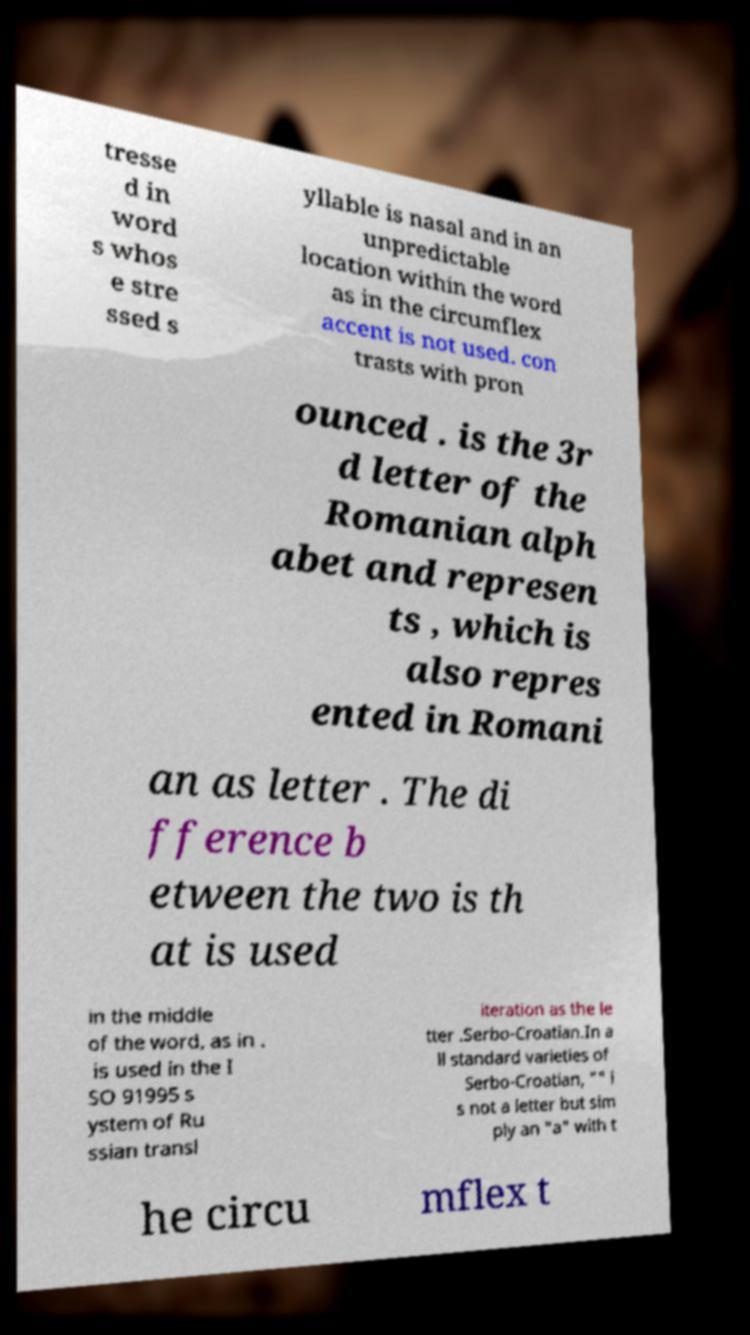There's text embedded in this image that I need extracted. Can you transcribe it verbatim? tresse d in word s whos e stre ssed s yllable is nasal and in an unpredictable location within the word as in the circumflex accent is not used. con trasts with pron ounced . is the 3r d letter of the Romanian alph abet and represen ts , which is also repres ented in Romani an as letter . The di fference b etween the two is th at is used in the middle of the word, as in . is used in the I SO 91995 s ystem of Ru ssian transl iteration as the le tter .Serbo-Croatian.In a ll standard varieties of Serbo-Croatian, "" i s not a letter but sim ply an "a" with t he circu mflex t 